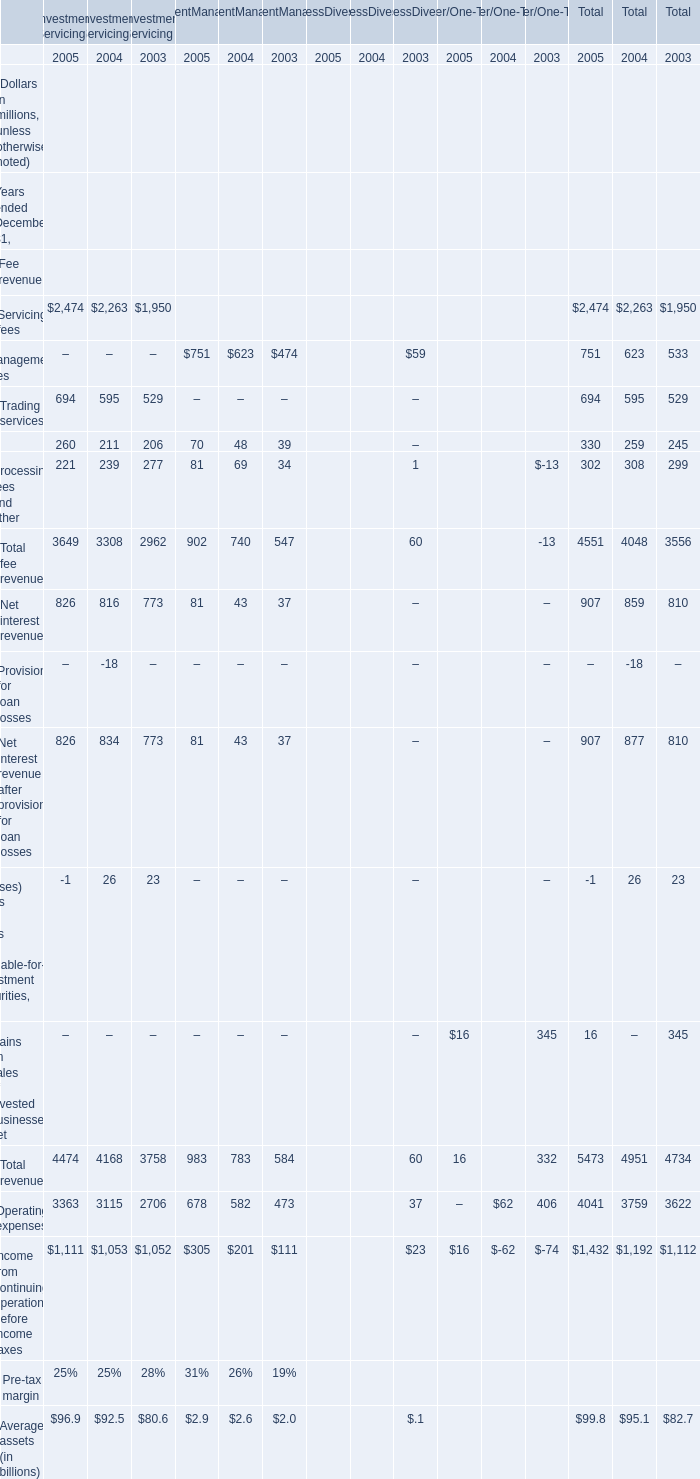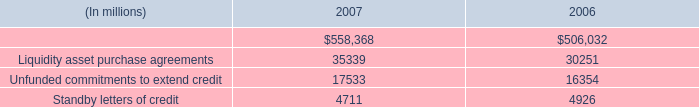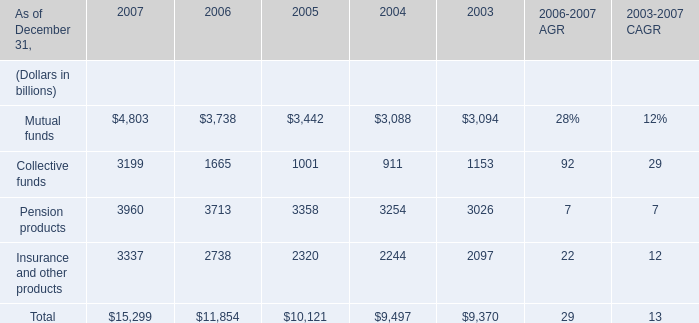what is the growth rate in the balance of standby letters of credit from 2006 to 2007? 
Computations: ((4711 - 4926) / 4926)
Answer: -0.04365. 